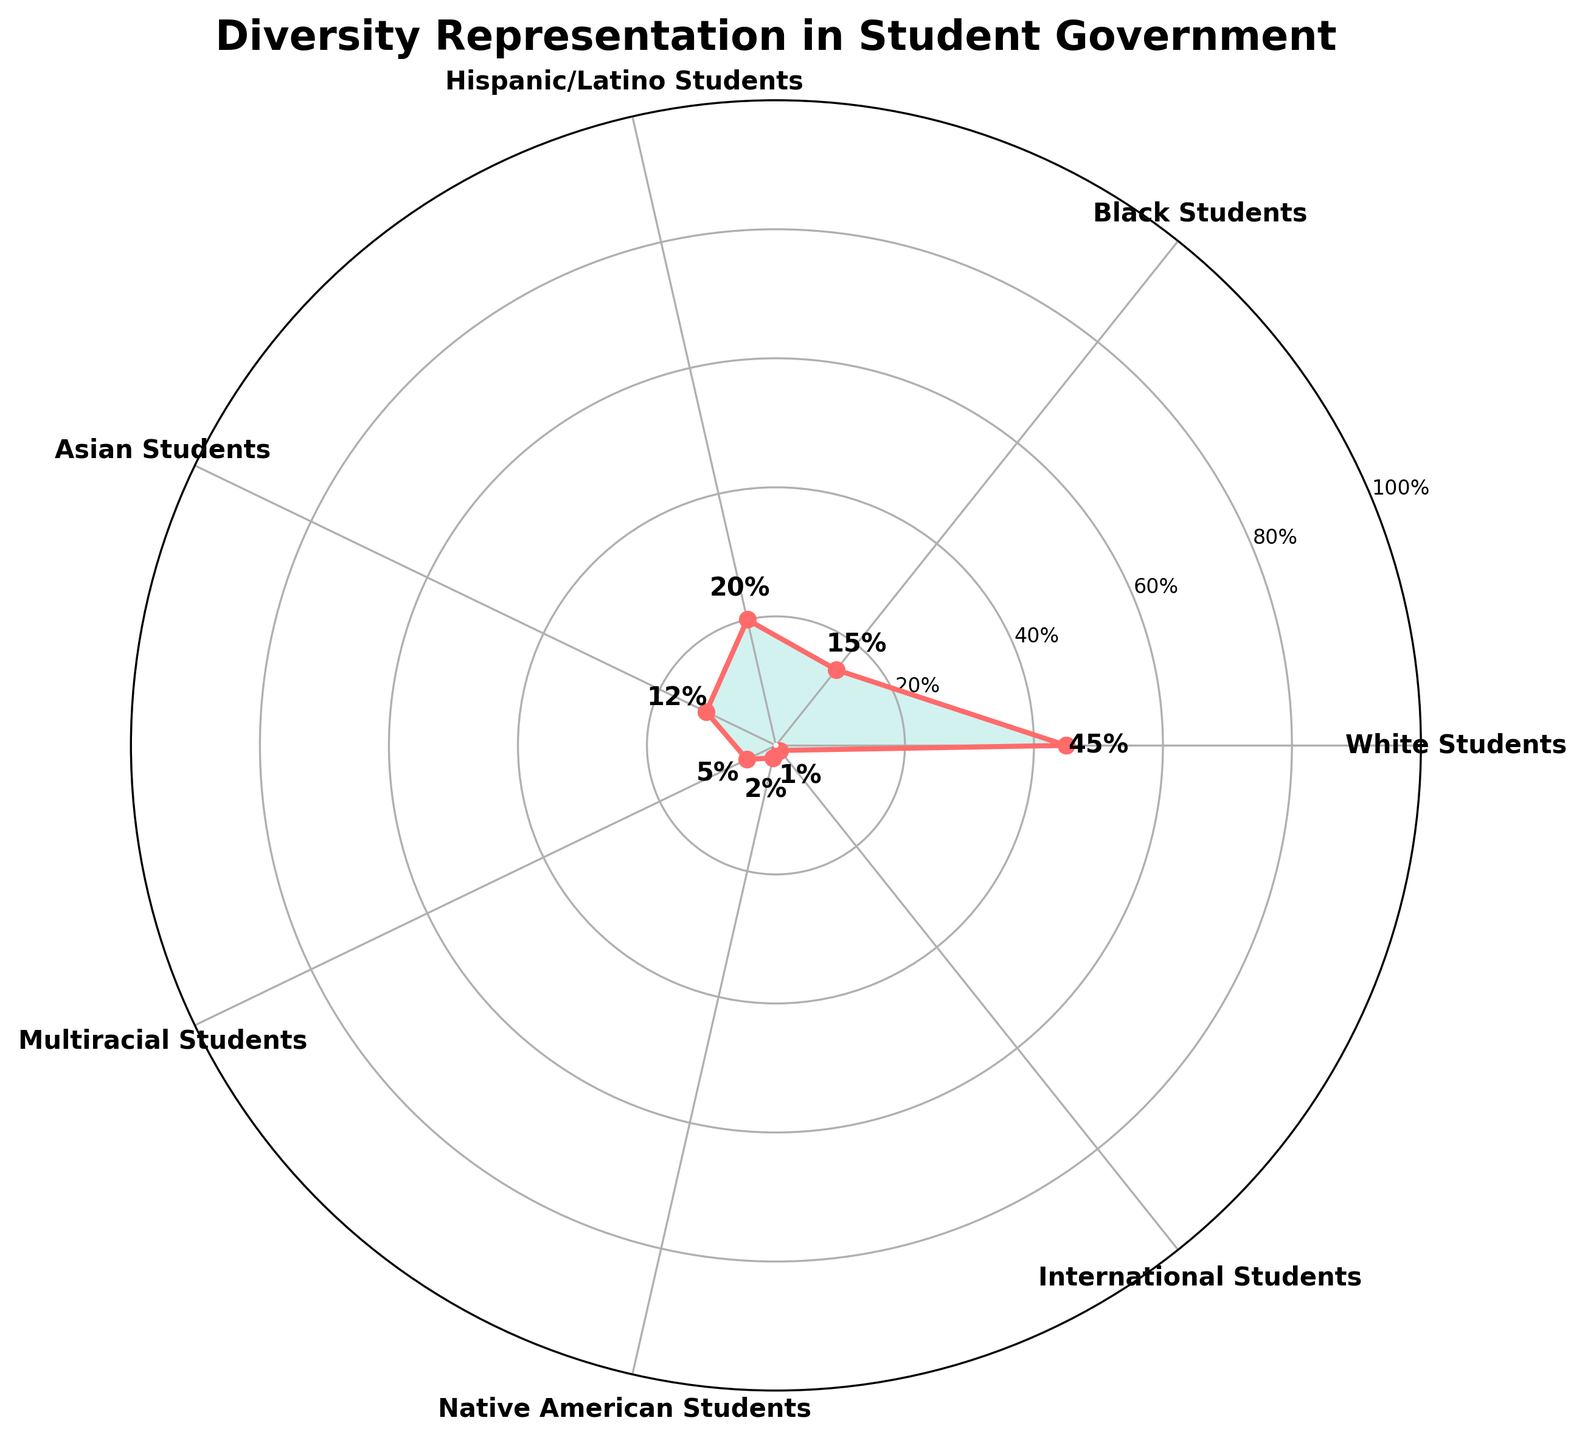What is the title of the chart? The title of the chart is displayed at the top and it reads "Diversity Representation in Student Government".
Answer: Diversity Representation in Student Government How many distinct student categories are represented in the chart? The chart shows different categories in a circular layout, and counting these gives us seven distinct student categories.
Answer: Seven Which student group has the highest representation in student government positions? By observing the percentages along the outer circle, the student group with the highest percentage is identified as White Students with 45%.
Answer: White Students What percentage of student government positions do Hispanic/Latino students hold? The chart visually represents the percentage for each category and Hispanic/Latino students hold 20% of the positions.
Answer: 20% How much higher is the percentage of White Students in student government compared to Asian Students? The chart shows White Students at 45% and Asian Students at 12%. The difference is calculated as 45% - 12% = 33%.
Answer: 33% What's the combined representation percentage of Black Students and Hispanic/Latino Students? Adding the percentages of Black Students (15%) and Hispanic/Latino Students (20%) results in 15% + 20% = 35%.
Answer: 35% Which student group has the lowest representation in student government positions? By looking at the percentages on the chart, International Students have the lowest representation with 1%.
Answer: International Students Are there any student groups with equal representation percentages? Examining the percentages given to the student categories, no groups have exactly the same percentage.
Answer: No How does the representation of Multiracial Students compare to that of Native American Students? The chart indicates Multiracial Students have 5% and Native American Students have 2%. This shows Multiracial Students have a higher representation.
Answer: Multiracial Students have higher representation What is the average percentage representation of all student groups in the chart? Summing all percentages (45% + 15% + 20% + 12% + 5% + 2% + 1% = 100%) and dividing by 7 categories, the average is 100% / 7 ≈ 14.29%.
Answer: 14.29% 